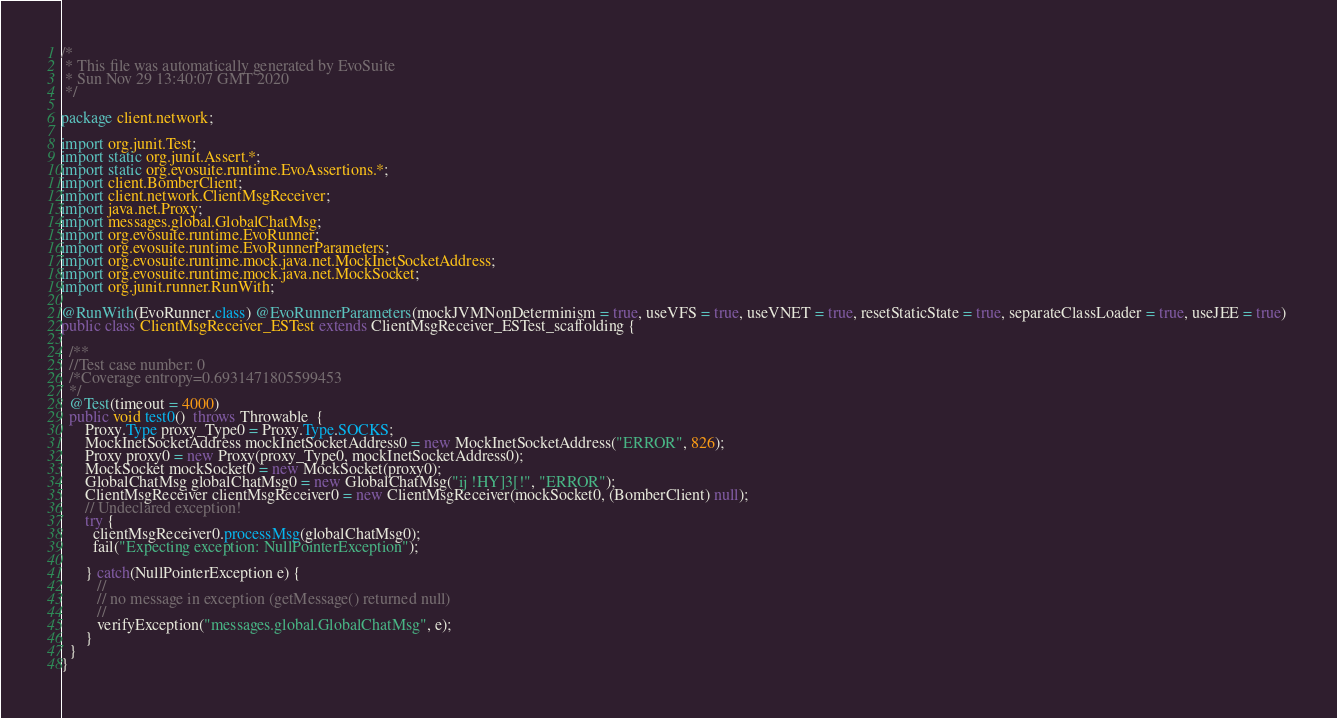Convert code to text. <code><loc_0><loc_0><loc_500><loc_500><_Java_>/*
 * This file was automatically generated by EvoSuite
 * Sun Nov 29 13:40:07 GMT 2020
 */

package client.network;

import org.junit.Test;
import static org.junit.Assert.*;
import static org.evosuite.runtime.EvoAssertions.*;
import client.BomberClient;
import client.network.ClientMsgReceiver;
import java.net.Proxy;
import messages.global.GlobalChatMsg;
import org.evosuite.runtime.EvoRunner;
import org.evosuite.runtime.EvoRunnerParameters;
import org.evosuite.runtime.mock.java.net.MockInetSocketAddress;
import org.evosuite.runtime.mock.java.net.MockSocket;
import org.junit.runner.RunWith;

@RunWith(EvoRunner.class) @EvoRunnerParameters(mockJVMNonDeterminism = true, useVFS = true, useVNET = true, resetStaticState = true, separateClassLoader = true, useJEE = true) 
public class ClientMsgReceiver_ESTest extends ClientMsgReceiver_ESTest_scaffolding {

  /**
  //Test case number: 0
  /*Coverage entropy=0.6931471805599453
  */
  @Test(timeout = 4000)
  public void test0()  throws Throwable  {
      Proxy.Type proxy_Type0 = Proxy.Type.SOCKS;
      MockInetSocketAddress mockInetSocketAddress0 = new MockInetSocketAddress("ERROR", 826);
      Proxy proxy0 = new Proxy(proxy_Type0, mockInetSocketAddress0);
      MockSocket mockSocket0 = new MockSocket(proxy0);
      GlobalChatMsg globalChatMsg0 = new GlobalChatMsg("ij!HY]3[!", "ERROR");
      ClientMsgReceiver clientMsgReceiver0 = new ClientMsgReceiver(mockSocket0, (BomberClient) null);
      // Undeclared exception!
      try { 
        clientMsgReceiver0.processMsg(globalChatMsg0);
        fail("Expecting exception: NullPointerException");
      
      } catch(NullPointerException e) {
         //
         // no message in exception (getMessage() returned null)
         //
         verifyException("messages.global.GlobalChatMsg", e);
      }
  }
}
</code> 